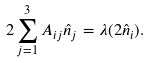Convert formula to latex. <formula><loc_0><loc_0><loc_500><loc_500>2 \sum _ { j = 1 } ^ { 3 } A _ { i j } \hat { n } _ { j } = \lambda ( 2 \hat { n } _ { i } ) .</formula> 